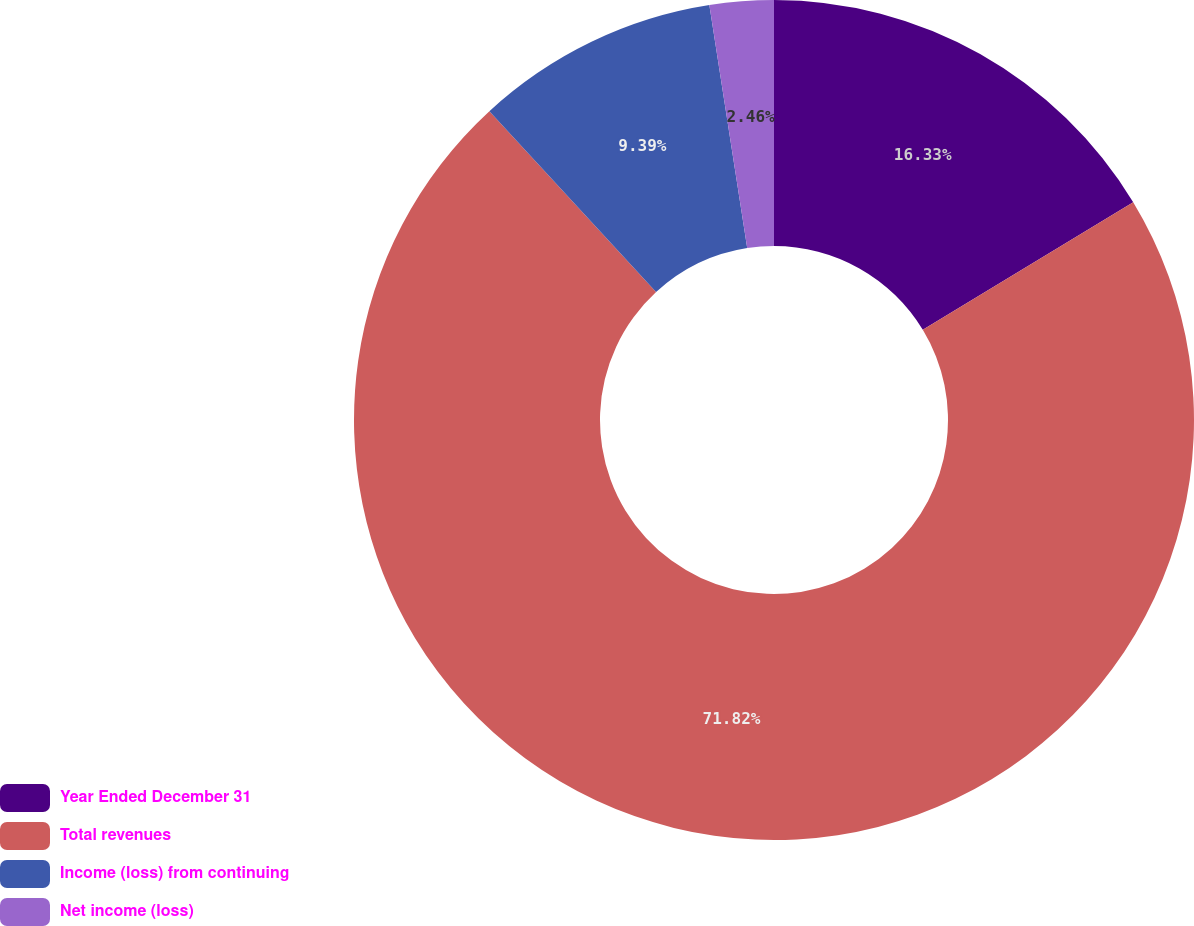Convert chart to OTSL. <chart><loc_0><loc_0><loc_500><loc_500><pie_chart><fcel>Year Ended December 31<fcel>Total revenues<fcel>Income (loss) from continuing<fcel>Net income (loss)<nl><fcel>16.33%<fcel>71.82%<fcel>9.39%<fcel>2.46%<nl></chart> 